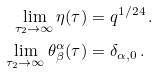Convert formula to latex. <formula><loc_0><loc_0><loc_500><loc_500>\lim _ { \tau _ { 2 } \to \infty } \eta ( \tau ) & = q ^ { 1 / 2 4 } \, . \\ \lim _ { \tau _ { 2 } \to \infty } \theta ^ { \alpha } _ { \beta } ( \tau ) & = \delta _ { \alpha , 0 } \, .</formula> 